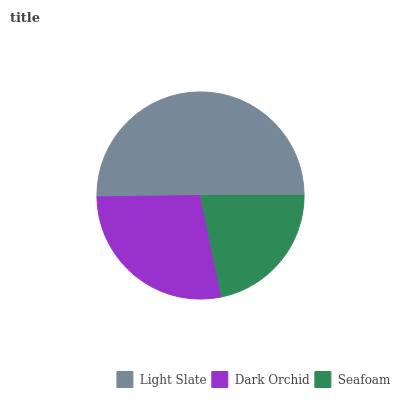Is Seafoam the minimum?
Answer yes or no. Yes. Is Light Slate the maximum?
Answer yes or no. Yes. Is Dark Orchid the minimum?
Answer yes or no. No. Is Dark Orchid the maximum?
Answer yes or no. No. Is Light Slate greater than Dark Orchid?
Answer yes or no. Yes. Is Dark Orchid less than Light Slate?
Answer yes or no. Yes. Is Dark Orchid greater than Light Slate?
Answer yes or no. No. Is Light Slate less than Dark Orchid?
Answer yes or no. No. Is Dark Orchid the high median?
Answer yes or no. Yes. Is Dark Orchid the low median?
Answer yes or no. Yes. Is Light Slate the high median?
Answer yes or no. No. Is Seafoam the low median?
Answer yes or no. No. 